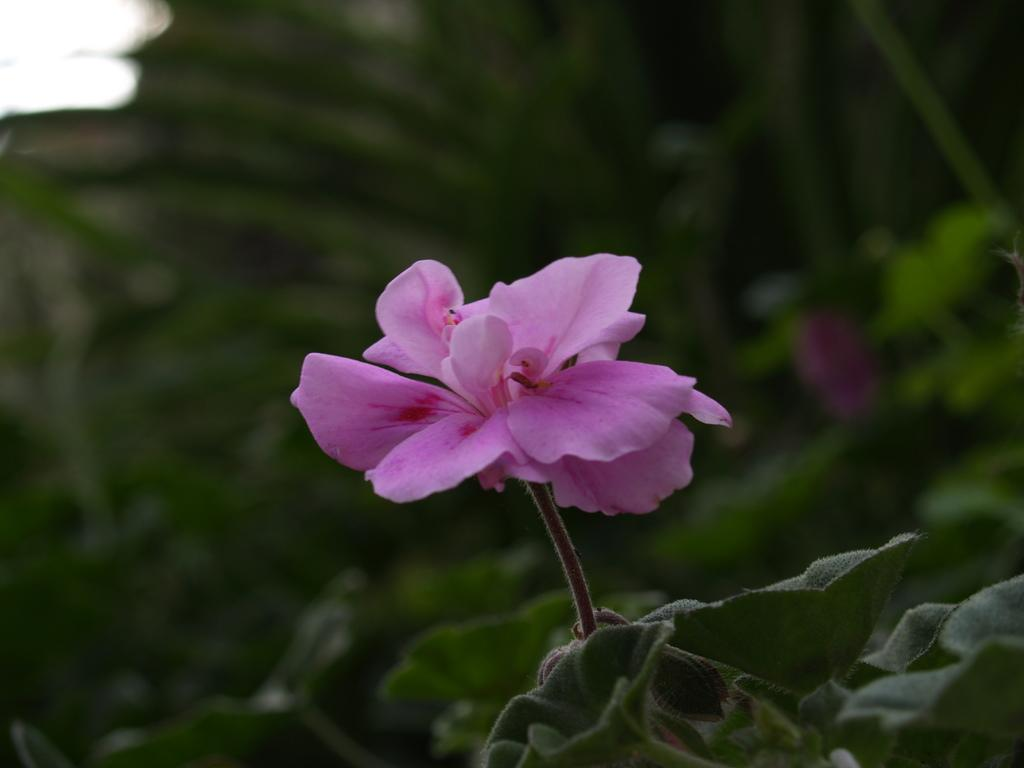What type of plant is featured in the image? There is a plant with a flower in the image. What color is the flower on the plant? The flower is pink in color. What are the main features of the flower? The flower has petals. What can be seen in the background of the image? There are other plants visible in the background of the image. What type of truck is visible in the image? There is no truck present in the image; it features a plant with a pink flower. Can you describe the exchange between the stranger and the plant in the image? There is no stranger present in the image, and plants do not engage in exchanges. 